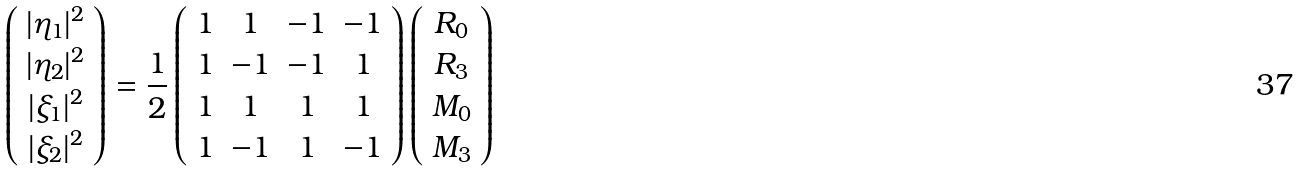<formula> <loc_0><loc_0><loc_500><loc_500>\left ( \begin{array} { c } | \eta _ { 1 } | ^ { 2 } \\ | \eta _ { 2 } | ^ { 2 } \\ | \xi _ { 1 } | ^ { 2 } \\ | \xi _ { 2 } | ^ { 2 } \end{array} \right ) = \frac { 1 } { 2 } \left ( \begin{array} { c c c c } 1 & 1 & - 1 & - 1 \\ 1 & - 1 & - 1 & 1 \\ 1 & 1 & 1 & 1 \\ 1 & - 1 & 1 & - 1 \end{array} \right ) \left ( \begin{array} { c } R _ { 0 } \\ R _ { 3 } \\ M _ { 0 } \\ M _ { 3 } \end{array} \right )</formula> 